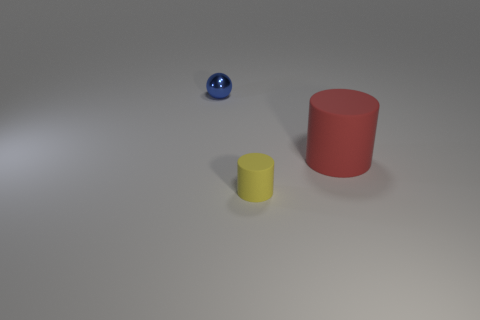What number of things are either blue metallic things or small objects behind the tiny matte thing?
Provide a short and direct response. 1. There is a small thing on the right side of the blue object; what is its color?
Your answer should be compact. Yellow. The yellow rubber object has what shape?
Provide a short and direct response. Cylinder. What is the material of the small blue thing that is behind the rubber thing in front of the big red rubber cylinder?
Provide a short and direct response. Metal. What number of other things are the same material as the tiny yellow cylinder?
Provide a succinct answer. 1. There is a yellow thing that is the same size as the metal sphere; what is its material?
Give a very brief answer. Rubber. Is the number of balls behind the red object greater than the number of matte things that are behind the yellow thing?
Ensure brevity in your answer.  No. Is there a gray shiny thing of the same shape as the tiny yellow thing?
Give a very brief answer. No. What shape is the other thing that is the same size as the blue thing?
Keep it short and to the point. Cylinder. There is a small thing on the left side of the yellow cylinder; what is its shape?
Keep it short and to the point. Sphere. 